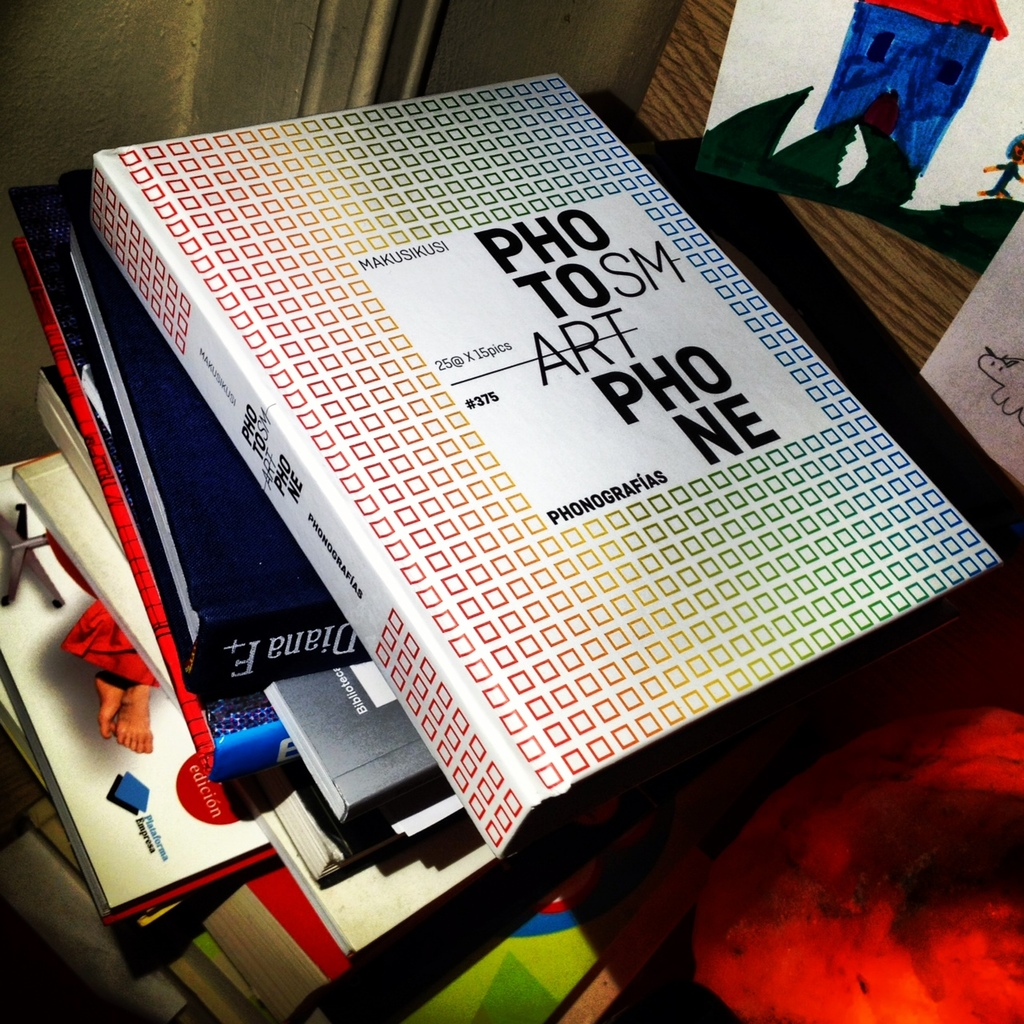What does the title 'PHOTOSMART' on the book suggest about its content? The title 'PHOTOSMART' likely suggests that the book covers topics related to photography and possibly its intersection with smart technology or intelligent photographic techniques. 